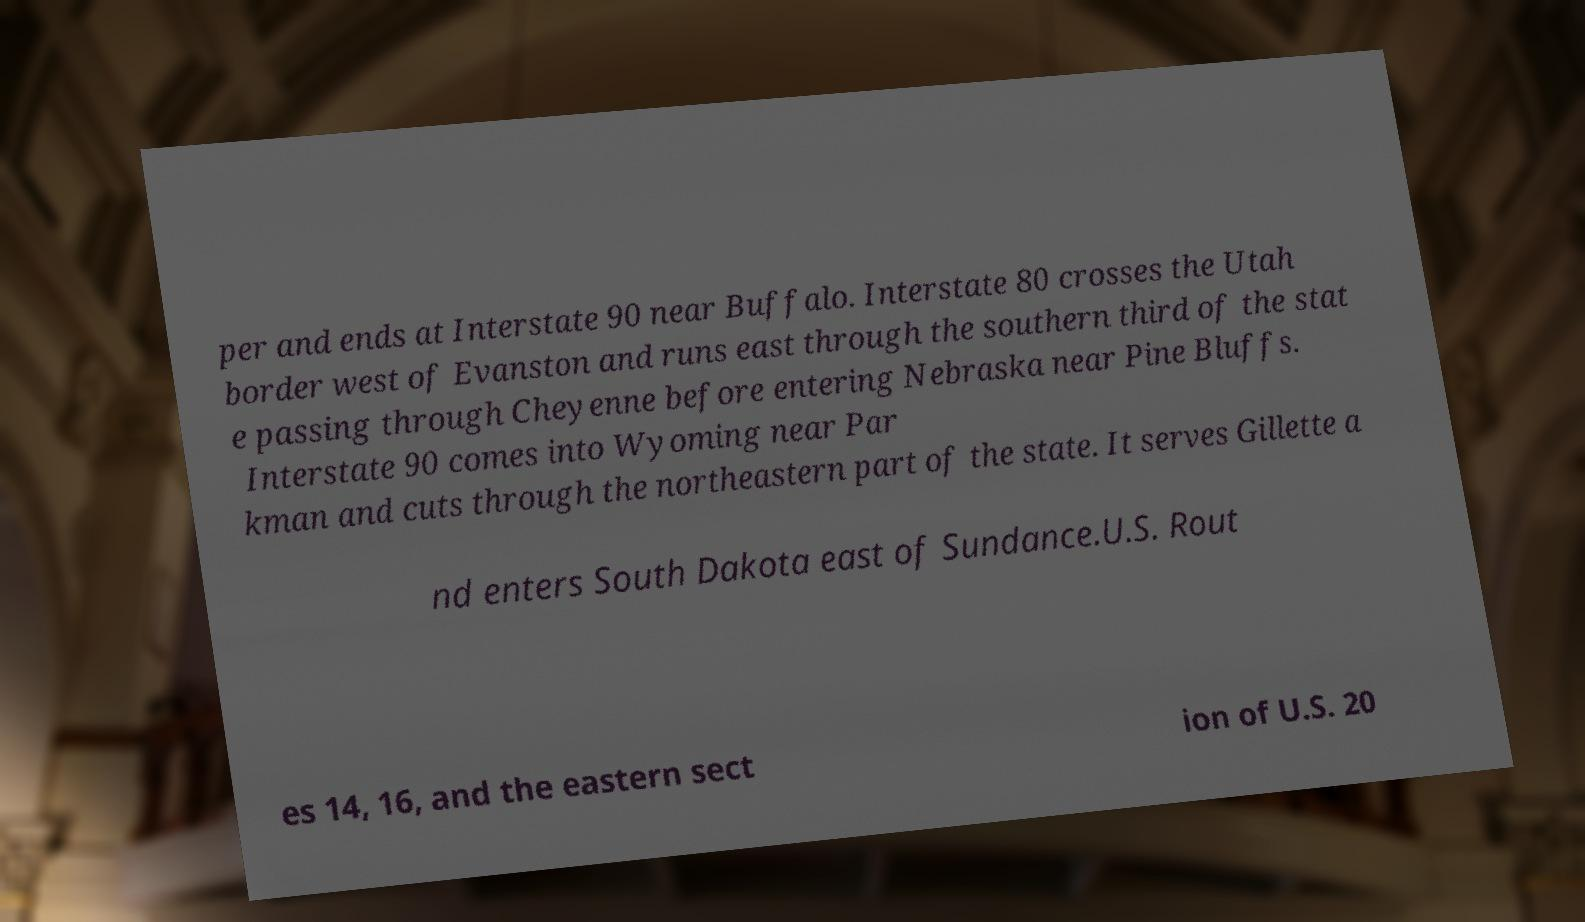Can you accurately transcribe the text from the provided image for me? per and ends at Interstate 90 near Buffalo. Interstate 80 crosses the Utah border west of Evanston and runs east through the southern third of the stat e passing through Cheyenne before entering Nebraska near Pine Bluffs. Interstate 90 comes into Wyoming near Par kman and cuts through the northeastern part of the state. It serves Gillette a nd enters South Dakota east of Sundance.U.S. Rout es 14, 16, and the eastern sect ion of U.S. 20 